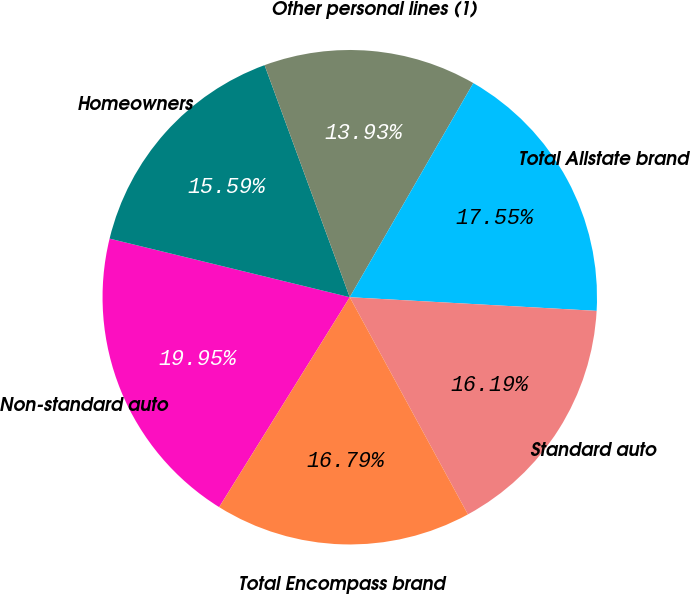Convert chart. <chart><loc_0><loc_0><loc_500><loc_500><pie_chart><fcel>Non-standard auto<fcel>Homeowners<fcel>Other personal lines (1)<fcel>Total Allstate brand<fcel>Standard auto<fcel>Total Encompass brand<nl><fcel>19.95%<fcel>15.59%<fcel>13.93%<fcel>17.55%<fcel>16.19%<fcel>16.79%<nl></chart> 